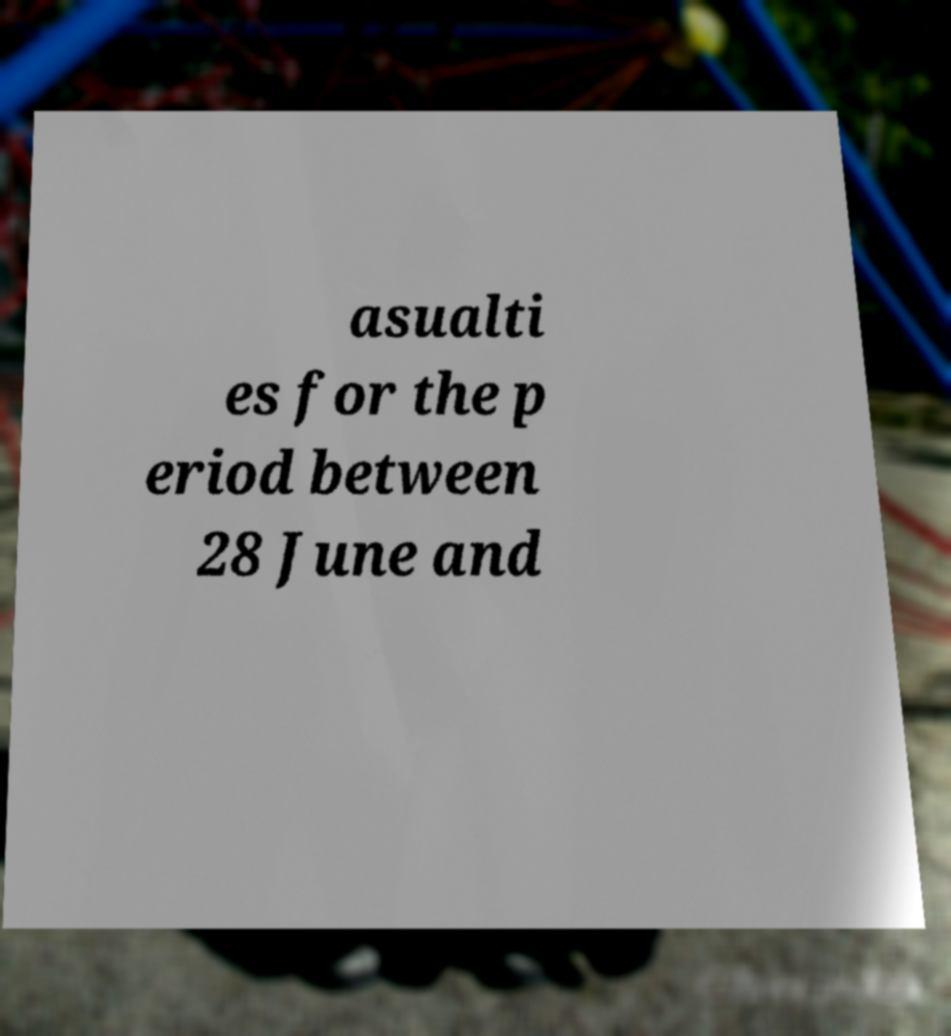I need the written content from this picture converted into text. Can you do that? asualti es for the p eriod between 28 June and 